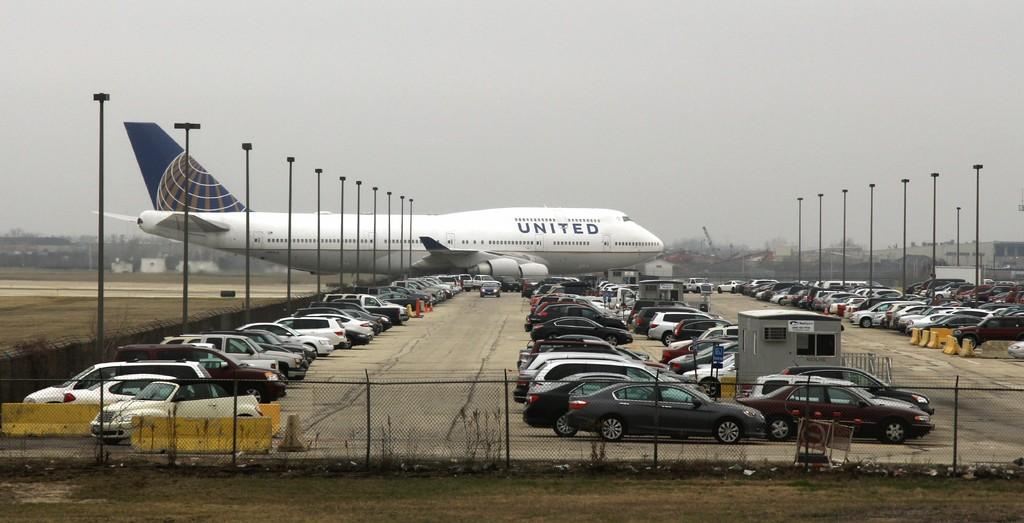<image>
Give a short and clear explanation of the subsequent image. White United airplane parked in a lot with cars. 